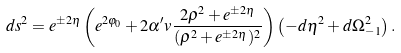Convert formula to latex. <formula><loc_0><loc_0><loc_500><loc_500>d s ^ { 2 } = e ^ { \pm 2 \eta } \left ( e ^ { 2 \varphi _ { 0 } } + 2 \alpha ^ { \prime } v \frac { 2 \rho ^ { 2 } + e ^ { \pm 2 \eta } } { ( \rho ^ { 2 } + e ^ { \pm 2 \eta } ) ^ { 2 } } \right ) \left ( - d \eta ^ { 2 } + d \Omega _ { - 1 } ^ { 2 } \right ) .</formula> 